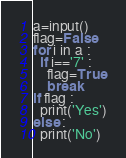<code> <loc_0><loc_0><loc_500><loc_500><_Python_>a=input()
flag=False
for i in a :
  if i=='7' :
    flag=True
    break
if flag :
  print('Yes')
else :
  print('No')</code> 